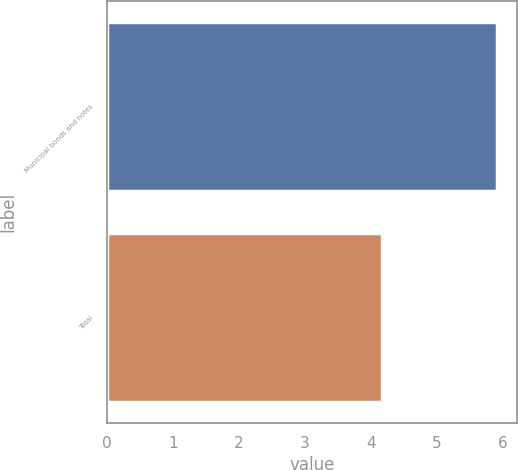<chart> <loc_0><loc_0><loc_500><loc_500><bar_chart><fcel>Municipal bonds and notes<fcel>Total<nl><fcel>5.91<fcel>4.17<nl></chart> 